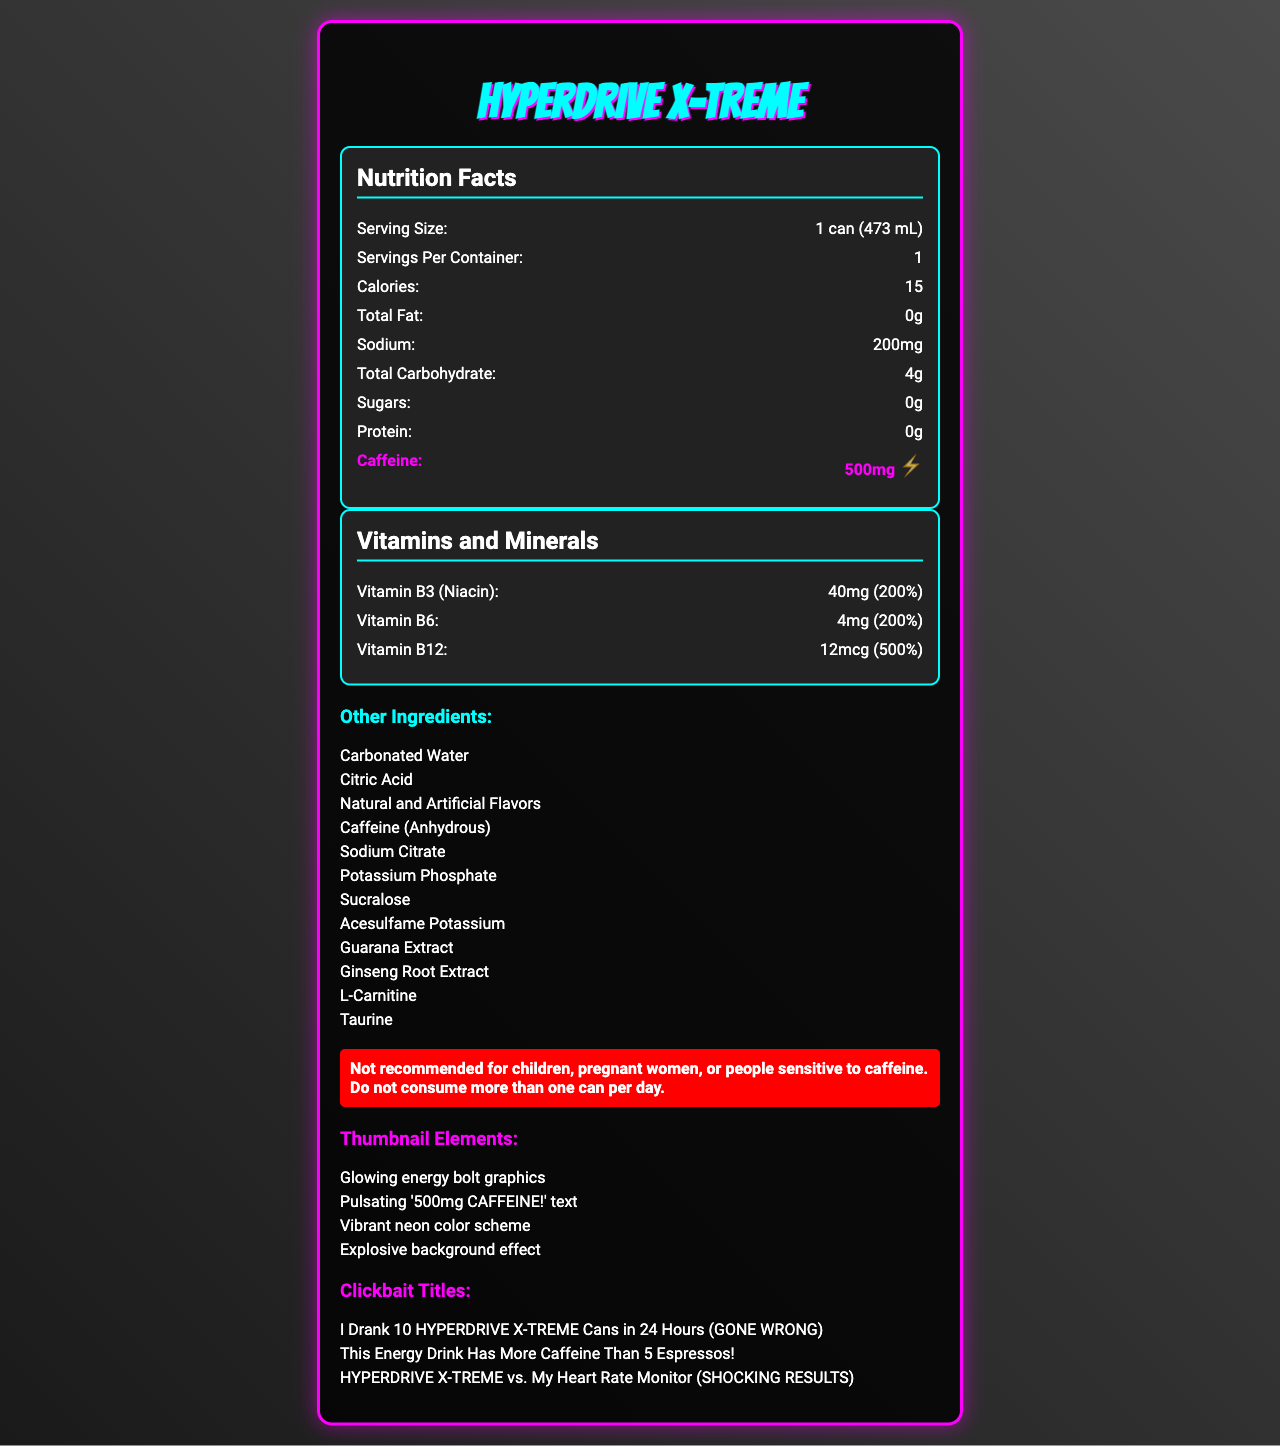what is the serving size for HYPERDRIVE X-TREME? The document states that the serving size is "1 can (473 mL)" in the "Nutrition Facts" section.
Answer: 1 can (473 mL) how many calories are in one serving of HYPERDRIVE X-TREME? The "Nutrition Facts" section mentions that there are 15 calories per serving.
Answer: 15 what is the amount of caffeine in one can of HYPERDRIVE X-TREME? The "Nutrition Facts" section highlights that there are 500mg of caffeine per serving.
Answer: 500mg what vitamins and amounts are in one can of HYPERDRIVE X-TREME? The document lists three vitamins with their respective amounts: Vitamin B3 (Niacin) 40mg, Vitamin B6 4mg, and Vitamin B12 12mcg.
Answer: Vitamin B3 (40mg), Vitamin B6 (4mg), Vitamin B12 (12mcg) what is the sodium content in one serving of HYPERDRIVE X-TREME? The "Nutrition Facts" section indicates that the sodium content is 200mg per serving.
Answer: 200mg which of the following ingredients are NOT in HYPERDRIVE X-TREME? A. Taurine B. Sucralose C. Aspartame D. Caffeine (Anhydrous) The ingredients listed for HYPERDRIVE X-TREME include Taurine, Sucralose, and Caffeine (Anhydrous) but not Aspartame.
Answer: C how many servings are in one container of HYPERDRIVE X-TREME? The "Nutrition Facts" section mentions that there is 1 serving per container.
Answer: 1 how much total carbohydrate is in one can? A. 0g B. 2g C. 4g D. 6g The "Nutrition Facts" section specifies that there are 4g of total carbohydrate per serving.
Answer: C is it recommended for children to consume HYPERDRIVE X-TREME? The warning section clearly states that the product is "Not recommended for children".
Answer: No describe the main purpose of the document. The document includes "Nutrition Facts", a detailed list of vitamins and minerals, other ingredients, a warning, suggested thumbnail elements, and clickbait titles meant to attract viewers.
Answer: The document provides detailed nutrition information, ingredients, warning, and creative elements for an energy drink called HYPERDRIVE X-TREME. what is the percentage of daily value for Vitamin B12 in HYPERDRIVE X-TREME? The document states that Vitamin B12 in the drink provides 500% of the daily value.
Answer: 500% which graphic elements are suggested for thumbnails? A. Explosive background effect B. Cartoon characters C. Minimalist design D. Monochrome color scheme The document lists "Glowing energy bolt graphics", "Pulsating '500mg CAFFEINE!' text", "Vibrant neon color scheme", and "Explosive background effect" as the suggested elements.
Answer: A who should avoid consuming HYPERDRIVE X-TREME according to the document? The warning section advises that children, pregnant women, and people sensitive to caffeine should avoid consuming the drink.
Answer: Children, pregnant women, people sensitive to caffeine how many milligrams of Vitamin B3 does HYPERDRIVE X-TREME contain? The document under the "Vitamins and Minerals" section lists 40mg of Vitamin B3.
Answer: 40mg does HYPERDRIVE X-TREME contain any protein? The "Nutrition Facts" section states that the protein content is 0g.
Answer: No what are the first three ingredients listed for HYPERDRIVE X-TREME? The "Other Ingredients" section lists these three ingredients first.
Answer: Carbonated Water, Citric Acid, Natural and Artificial Flavors which of the following titles is suggested as a clickbait title? A. "The Healthiest Drink Ever!" B. "I Drank 10 HYPERDRIVE X-TREME Cans in 24 Hours (GONE WRONG)" C. "The Perfect Hydration Solution" D. "Energy Without the Crash!" The document suggests "I Drank 10 HYPERDRIVE X-TREME Cans in 24 Hours (GONE WRONG)" as a clickbait title.
Answer: B what daily value percentage of Vitamin B6 is in the drink? The document specifies that Vitamin B6 in the drink provides 200% of the daily value.
Answer: 200% how much fat is in HYPERDRIVE X-TREME? The "Nutrition Facts" section indicates that the total fat content is 0g.
Answer: 0g what is the main idea of the warning provided in the document? The warning advises against consumption by children, pregnant women, and people sensitive to caffeine, and limits consumption to one can per day.
Answer: The drink is not recommended for certain groups, and consumption should be limited to one can per day. what other ingredients are unique to energy drinks like HYPERDRIVE X-TREME? The "Other Ingredients" section lists several ingredients typically found in energy drinks, such as Guarana Extract, Ginseng Root Extract, L-Carnitine, and Taurine.
Answer: Guarana Extract, Ginseng Root Extract, L-Carnitine, Taurine how many cans of HYPERDRIVE X-TREME are safe to consume per day according to the document? The warning section advises not to consume more than one can per day.
Answer: One can 